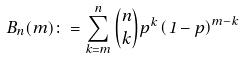Convert formula to latex. <formula><loc_0><loc_0><loc_500><loc_500>B _ { n } ( m ) \colon = { \sum _ { k = m } ^ { n } \binom { n } { k } p ^ { k } \left ( 1 - p \right ) ^ { m - k } }</formula> 